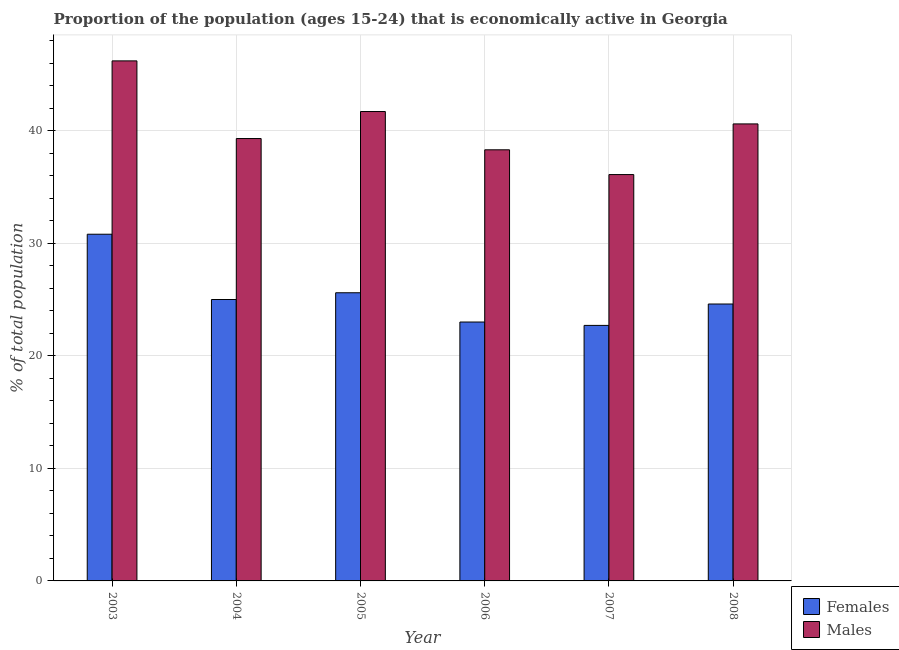How many bars are there on the 5th tick from the right?
Offer a terse response. 2. In how many cases, is the number of bars for a given year not equal to the number of legend labels?
Provide a short and direct response. 0. What is the percentage of economically active female population in 2007?
Ensure brevity in your answer.  22.7. Across all years, what is the maximum percentage of economically active male population?
Give a very brief answer. 46.2. Across all years, what is the minimum percentage of economically active female population?
Offer a terse response. 22.7. What is the total percentage of economically active female population in the graph?
Give a very brief answer. 151.7. What is the difference between the percentage of economically active male population in 2006 and that in 2008?
Provide a short and direct response. -2.3. What is the difference between the percentage of economically active female population in 2005 and the percentage of economically active male population in 2006?
Make the answer very short. 2.6. What is the average percentage of economically active female population per year?
Offer a very short reply. 25.28. In the year 2007, what is the difference between the percentage of economically active male population and percentage of economically active female population?
Provide a succinct answer. 0. What is the ratio of the percentage of economically active female population in 2003 to that in 2006?
Provide a succinct answer. 1.34. Is the percentage of economically active male population in 2004 less than that in 2005?
Ensure brevity in your answer.  Yes. What is the difference between the highest and the second highest percentage of economically active female population?
Provide a short and direct response. 5.2. What is the difference between the highest and the lowest percentage of economically active male population?
Keep it short and to the point. 10.1. Is the sum of the percentage of economically active female population in 2004 and 2007 greater than the maximum percentage of economically active male population across all years?
Your answer should be very brief. Yes. What does the 2nd bar from the left in 2006 represents?
Your answer should be compact. Males. What does the 1st bar from the right in 2006 represents?
Your response must be concise. Males. Are all the bars in the graph horizontal?
Your response must be concise. No. How many years are there in the graph?
Ensure brevity in your answer.  6. What is the difference between two consecutive major ticks on the Y-axis?
Your answer should be very brief. 10. Where does the legend appear in the graph?
Your response must be concise. Bottom right. How are the legend labels stacked?
Make the answer very short. Vertical. What is the title of the graph?
Keep it short and to the point. Proportion of the population (ages 15-24) that is economically active in Georgia. Does "Malaria" appear as one of the legend labels in the graph?
Your response must be concise. No. What is the label or title of the X-axis?
Make the answer very short. Year. What is the label or title of the Y-axis?
Give a very brief answer. % of total population. What is the % of total population in Females in 2003?
Your answer should be very brief. 30.8. What is the % of total population in Males in 2003?
Your answer should be very brief. 46.2. What is the % of total population of Females in 2004?
Give a very brief answer. 25. What is the % of total population of Males in 2004?
Offer a terse response. 39.3. What is the % of total population of Females in 2005?
Keep it short and to the point. 25.6. What is the % of total population of Males in 2005?
Provide a short and direct response. 41.7. What is the % of total population of Females in 2006?
Provide a succinct answer. 23. What is the % of total population of Males in 2006?
Provide a short and direct response. 38.3. What is the % of total population in Females in 2007?
Ensure brevity in your answer.  22.7. What is the % of total population in Males in 2007?
Your answer should be very brief. 36.1. What is the % of total population in Females in 2008?
Give a very brief answer. 24.6. What is the % of total population of Males in 2008?
Your answer should be very brief. 40.6. Across all years, what is the maximum % of total population in Females?
Ensure brevity in your answer.  30.8. Across all years, what is the maximum % of total population of Males?
Ensure brevity in your answer.  46.2. Across all years, what is the minimum % of total population in Females?
Keep it short and to the point. 22.7. Across all years, what is the minimum % of total population in Males?
Make the answer very short. 36.1. What is the total % of total population of Females in the graph?
Offer a very short reply. 151.7. What is the total % of total population of Males in the graph?
Ensure brevity in your answer.  242.2. What is the difference between the % of total population in Females in 2003 and that in 2004?
Give a very brief answer. 5.8. What is the difference between the % of total population of Males in 2003 and that in 2004?
Ensure brevity in your answer.  6.9. What is the difference between the % of total population in Females in 2003 and that in 2006?
Your answer should be compact. 7.8. What is the difference between the % of total population of Males in 2003 and that in 2006?
Ensure brevity in your answer.  7.9. What is the difference between the % of total population of Males in 2003 and that in 2007?
Your answer should be compact. 10.1. What is the difference between the % of total population in Females in 2003 and that in 2008?
Your answer should be compact. 6.2. What is the difference between the % of total population in Males in 2003 and that in 2008?
Provide a short and direct response. 5.6. What is the difference between the % of total population of Females in 2004 and that in 2007?
Offer a terse response. 2.3. What is the difference between the % of total population of Males in 2004 and that in 2007?
Offer a very short reply. 3.2. What is the difference between the % of total population in Males in 2005 and that in 2007?
Offer a terse response. 5.6. What is the difference between the % of total population of Males in 2005 and that in 2008?
Your response must be concise. 1.1. What is the difference between the % of total population in Females in 2006 and that in 2007?
Offer a very short reply. 0.3. What is the difference between the % of total population of Females in 2006 and that in 2008?
Provide a succinct answer. -1.6. What is the difference between the % of total population of Females in 2007 and that in 2008?
Give a very brief answer. -1.9. What is the difference between the % of total population of Males in 2007 and that in 2008?
Give a very brief answer. -4.5. What is the difference between the % of total population in Females in 2003 and the % of total population in Males in 2004?
Provide a succinct answer. -8.5. What is the difference between the % of total population in Females in 2003 and the % of total population in Males in 2005?
Provide a succinct answer. -10.9. What is the difference between the % of total population of Females in 2003 and the % of total population of Males in 2007?
Keep it short and to the point. -5.3. What is the difference between the % of total population in Females in 2003 and the % of total population in Males in 2008?
Keep it short and to the point. -9.8. What is the difference between the % of total population in Females in 2004 and the % of total population in Males in 2005?
Offer a terse response. -16.7. What is the difference between the % of total population of Females in 2004 and the % of total population of Males in 2007?
Make the answer very short. -11.1. What is the difference between the % of total population in Females in 2004 and the % of total population in Males in 2008?
Offer a terse response. -15.6. What is the difference between the % of total population in Females in 2005 and the % of total population in Males in 2006?
Offer a terse response. -12.7. What is the difference between the % of total population in Females in 2005 and the % of total population in Males in 2007?
Your answer should be very brief. -10.5. What is the difference between the % of total population in Females in 2006 and the % of total population in Males in 2007?
Offer a very short reply. -13.1. What is the difference between the % of total population of Females in 2006 and the % of total population of Males in 2008?
Provide a succinct answer. -17.6. What is the difference between the % of total population of Females in 2007 and the % of total population of Males in 2008?
Offer a terse response. -17.9. What is the average % of total population in Females per year?
Provide a succinct answer. 25.28. What is the average % of total population in Males per year?
Your answer should be compact. 40.37. In the year 2003, what is the difference between the % of total population in Females and % of total population in Males?
Your answer should be very brief. -15.4. In the year 2004, what is the difference between the % of total population of Females and % of total population of Males?
Make the answer very short. -14.3. In the year 2005, what is the difference between the % of total population of Females and % of total population of Males?
Your answer should be compact. -16.1. In the year 2006, what is the difference between the % of total population in Females and % of total population in Males?
Make the answer very short. -15.3. In the year 2007, what is the difference between the % of total population in Females and % of total population in Males?
Ensure brevity in your answer.  -13.4. In the year 2008, what is the difference between the % of total population in Females and % of total population in Males?
Provide a short and direct response. -16. What is the ratio of the % of total population of Females in 2003 to that in 2004?
Offer a very short reply. 1.23. What is the ratio of the % of total population in Males in 2003 to that in 2004?
Offer a very short reply. 1.18. What is the ratio of the % of total population of Females in 2003 to that in 2005?
Keep it short and to the point. 1.2. What is the ratio of the % of total population in Males in 2003 to that in 2005?
Provide a succinct answer. 1.11. What is the ratio of the % of total population of Females in 2003 to that in 2006?
Your answer should be compact. 1.34. What is the ratio of the % of total population of Males in 2003 to that in 2006?
Offer a terse response. 1.21. What is the ratio of the % of total population in Females in 2003 to that in 2007?
Your response must be concise. 1.36. What is the ratio of the % of total population of Males in 2003 to that in 2007?
Your response must be concise. 1.28. What is the ratio of the % of total population of Females in 2003 to that in 2008?
Provide a succinct answer. 1.25. What is the ratio of the % of total population in Males in 2003 to that in 2008?
Your answer should be compact. 1.14. What is the ratio of the % of total population in Females in 2004 to that in 2005?
Ensure brevity in your answer.  0.98. What is the ratio of the % of total population in Males in 2004 to that in 2005?
Offer a terse response. 0.94. What is the ratio of the % of total population of Females in 2004 to that in 2006?
Provide a succinct answer. 1.09. What is the ratio of the % of total population in Males in 2004 to that in 2006?
Ensure brevity in your answer.  1.03. What is the ratio of the % of total population of Females in 2004 to that in 2007?
Your response must be concise. 1.1. What is the ratio of the % of total population in Males in 2004 to that in 2007?
Keep it short and to the point. 1.09. What is the ratio of the % of total population in Females in 2004 to that in 2008?
Make the answer very short. 1.02. What is the ratio of the % of total population of Females in 2005 to that in 2006?
Your response must be concise. 1.11. What is the ratio of the % of total population in Males in 2005 to that in 2006?
Ensure brevity in your answer.  1.09. What is the ratio of the % of total population of Females in 2005 to that in 2007?
Ensure brevity in your answer.  1.13. What is the ratio of the % of total population of Males in 2005 to that in 2007?
Offer a terse response. 1.16. What is the ratio of the % of total population of Females in 2005 to that in 2008?
Offer a terse response. 1.04. What is the ratio of the % of total population in Males in 2005 to that in 2008?
Offer a very short reply. 1.03. What is the ratio of the % of total population in Females in 2006 to that in 2007?
Make the answer very short. 1.01. What is the ratio of the % of total population in Males in 2006 to that in 2007?
Provide a short and direct response. 1.06. What is the ratio of the % of total population in Females in 2006 to that in 2008?
Your response must be concise. 0.94. What is the ratio of the % of total population in Males in 2006 to that in 2008?
Make the answer very short. 0.94. What is the ratio of the % of total population of Females in 2007 to that in 2008?
Your answer should be very brief. 0.92. What is the ratio of the % of total population in Males in 2007 to that in 2008?
Ensure brevity in your answer.  0.89. What is the difference between the highest and the second highest % of total population in Males?
Offer a very short reply. 4.5. What is the difference between the highest and the lowest % of total population of Males?
Your answer should be compact. 10.1. 